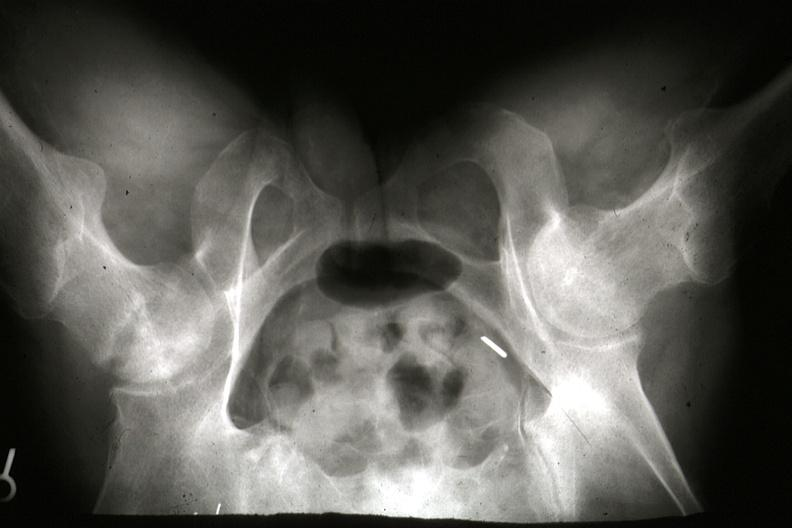how is x-ray of pelvis during life showing osteonecrosis in right head slides?
Answer the question using a single word or phrase. Femoral 